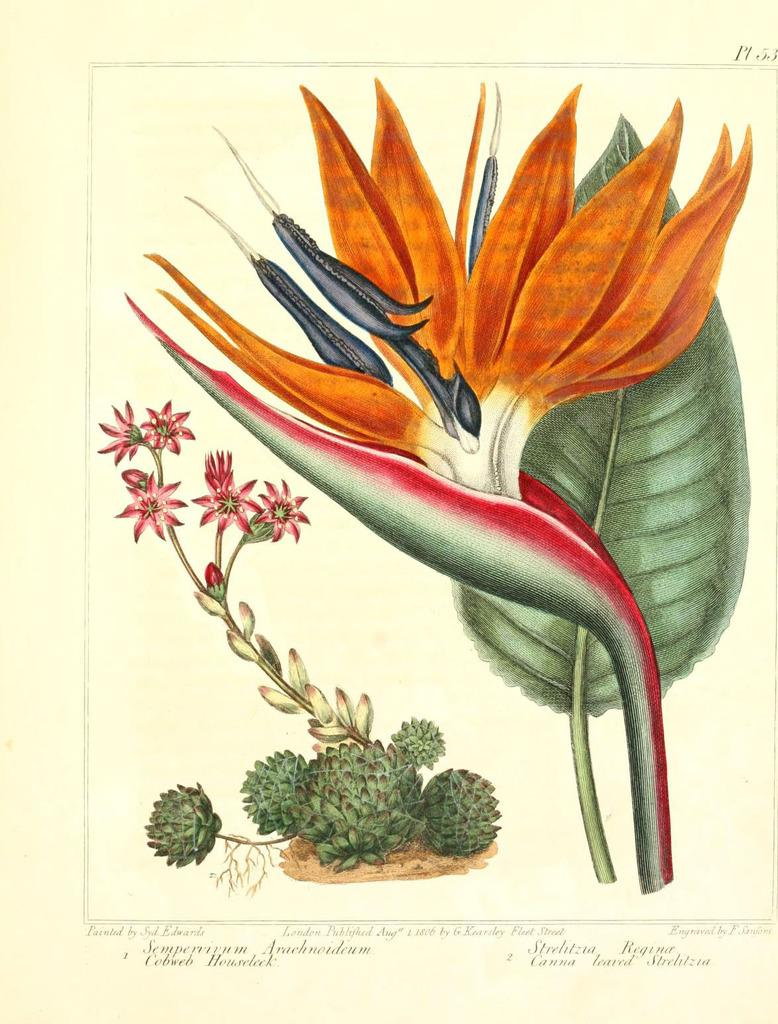What type of living organisms can be seen in the image? Plants are depicted in the image. What else can be found in the image besides plants? There is text present in the image. What is the weight of the bit in the image? There is no bit present in the image, so its weight cannot be determined. 